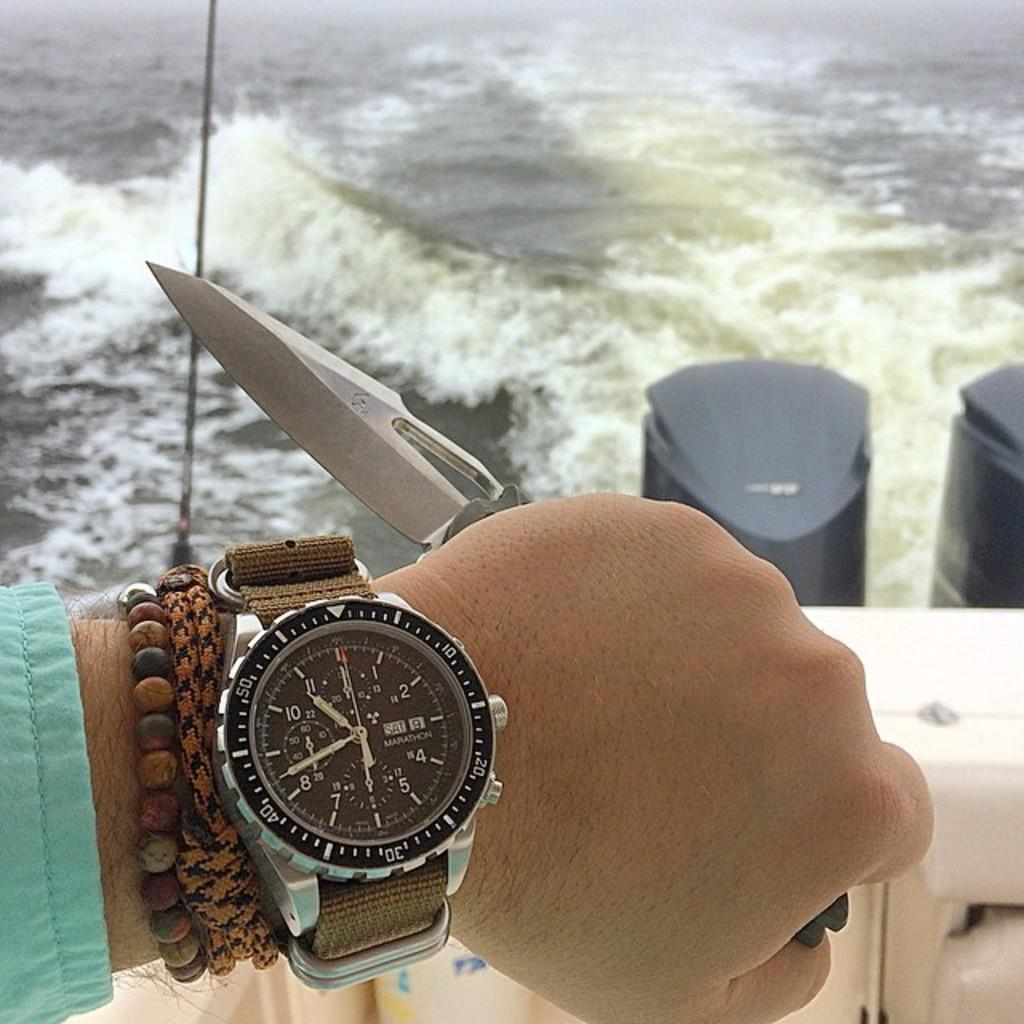<image>
Write a terse but informative summary of the picture. A MARATHON watch reads ten forty am on a boat. 